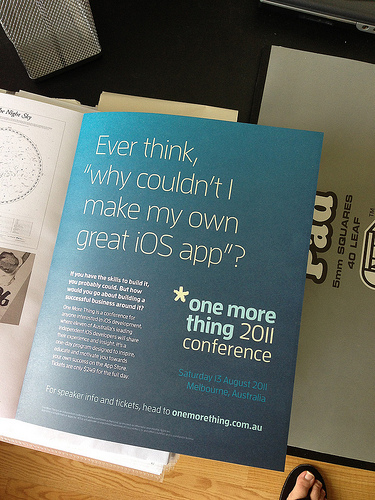<image>
Can you confirm if the asterisk is on the page? Yes. Looking at the image, I can see the asterisk is positioned on top of the page, with the page providing support. 